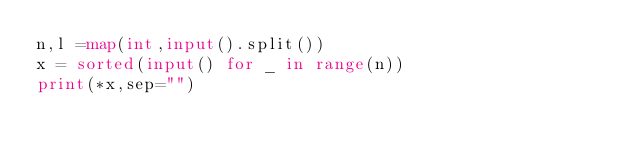<code> <loc_0><loc_0><loc_500><loc_500><_Python_>n,l =map(int,input().split())
x = sorted(input() for _ in range(n))
print(*x,sep="")</code> 